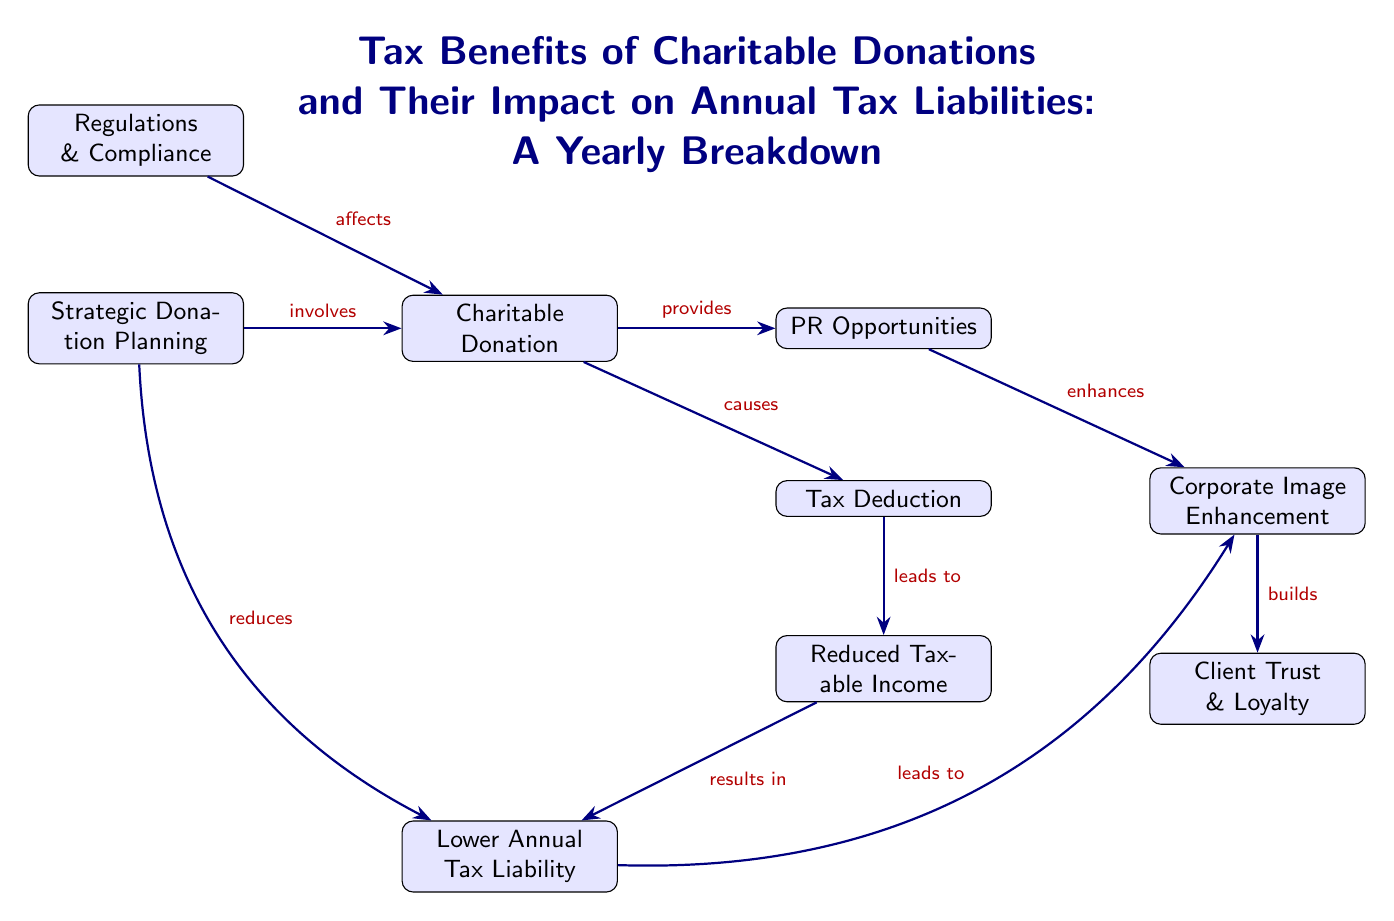What is the primary outcome of making a charitable donation? The diagram indicates that the primary outcome of making a charitable donation is a tax deduction, as shown by the arrow leading from "Charitable Donation" to "Tax Deduction."
Answer: Tax Deduction Which node indicates a benefit related to client trust? The node labeled "Client Trust & Loyalty" displays the benefit related to client trust, as it's directly connected below the node "Corporate Image Enhancement."
Answer: Client Trust & Loyalty What term describes the effect of reduced taxable income on annual tax liability? The diagram illustrates that reduced taxable income results in a lower annual tax liability, as evidenced by the arrow flowing from "Reduced Taxable Income" to "Lower Annual Tax Liability."
Answer: Lower Annual Tax Liability How does strategic donation planning affect charitable donations? Strategic donation planning involves the charitable donation process, as indicated by the arrow from "Strategic Donation Planning" to "Charitable Donation," which shows the involvement in the process.
Answer: Involves What connection is there between tax deductions and corporate image enhancement? The flow of the diagram does not indicate a direct connection between tax deductions and corporate image enhancement. However, it shows that a charitable donation leads to a tax deduction, and the donation also provides PR opportunities that enhance the corporate image.
Answer: No direct connection What regulatory aspect influences charitable donations? According to the diagram, the regulations and compliance node affects charitable donations, as indicated by the arrow directed toward "Charitable Donation."
Answer: Regulations & Compliance How many nodes are related to the outcomes of charitable donations? The outcomes of charitable donations are represented in the nodes: "Tax Deduction," "Reduced Taxable Income," "Lower Annual Tax Liability," and "PR Opportunities," totaling four nodes.
Answer: Four nodes What aspect builds client trust from PR opportunities? The diagram shows that corporate image enhancement builds client trust and loyalty, as visualized by the flow from "Corporate Image Enhancement" to "Client Trust & Loyalty."
Answer: Builds What is the link between charitable donation and tax liability reduction? The diagram illustrates that making a charitable donation leads to reduced taxable income, which ultimately lowers the annual tax liability, as indicated by the arrows connecting these nodes.
Answer: Lowers Annual Tax Liability 